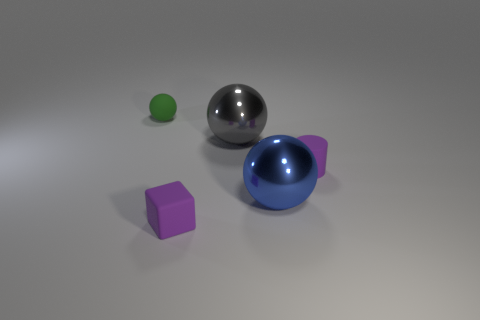Is there a large green metal sphere?
Provide a short and direct response. No. There is a gray metal object that is the same shape as the blue shiny object; what is its size?
Your answer should be very brief. Large. There is a small matte thing that is behind the purple thing that is behind the blue metallic thing; what shape is it?
Offer a very short reply. Sphere. How many blue objects are either cubes or large metallic blocks?
Provide a short and direct response. 0. What color is the rubber ball?
Offer a terse response. Green. Do the gray ball and the green object have the same size?
Provide a succinct answer. No. Is there anything else that is the same shape as the green object?
Your answer should be compact. Yes. Is the gray object made of the same material as the small green sphere to the left of the cylinder?
Offer a very short reply. No. There is a rubber object that is to the right of the gray object; is its color the same as the small matte block?
Your answer should be very brief. Yes. How many objects are both right of the cube and in front of the small purple cylinder?
Give a very brief answer. 1. 